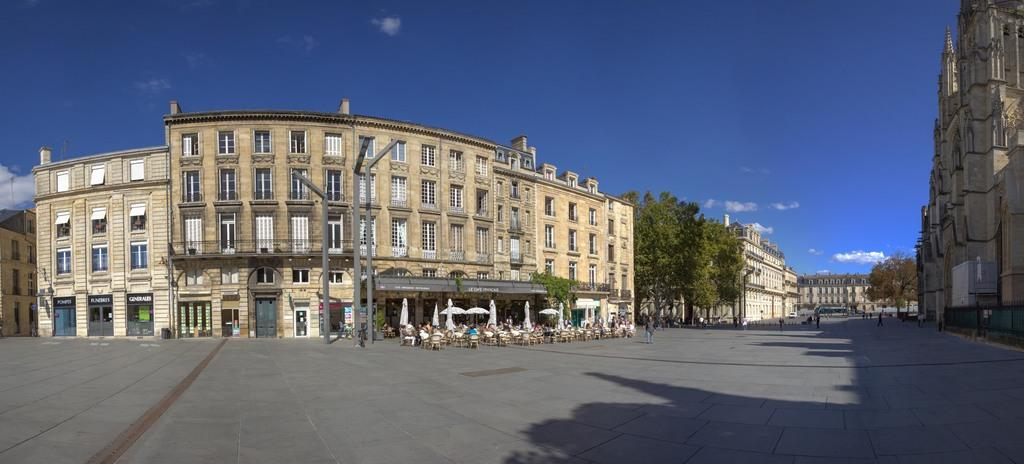What is the main feature of the image? There is a road in the image. What are the people in the image doing? People are walking on the road. What type of furniture can be seen in the image? There are tables and chairs in the image. What structures are present in the image? Light poles and stone buildings are visible in the image. What type of vegetation is in the image? Trees are in the image. What is the color of the sky in the background of the image? The sky is blue in the background of the image. Can you hear the people in the image laughing? There is no sound in the image, so it is not possible to hear the people laughing. Is there a cave visible in the image? There is no cave present in the image. 